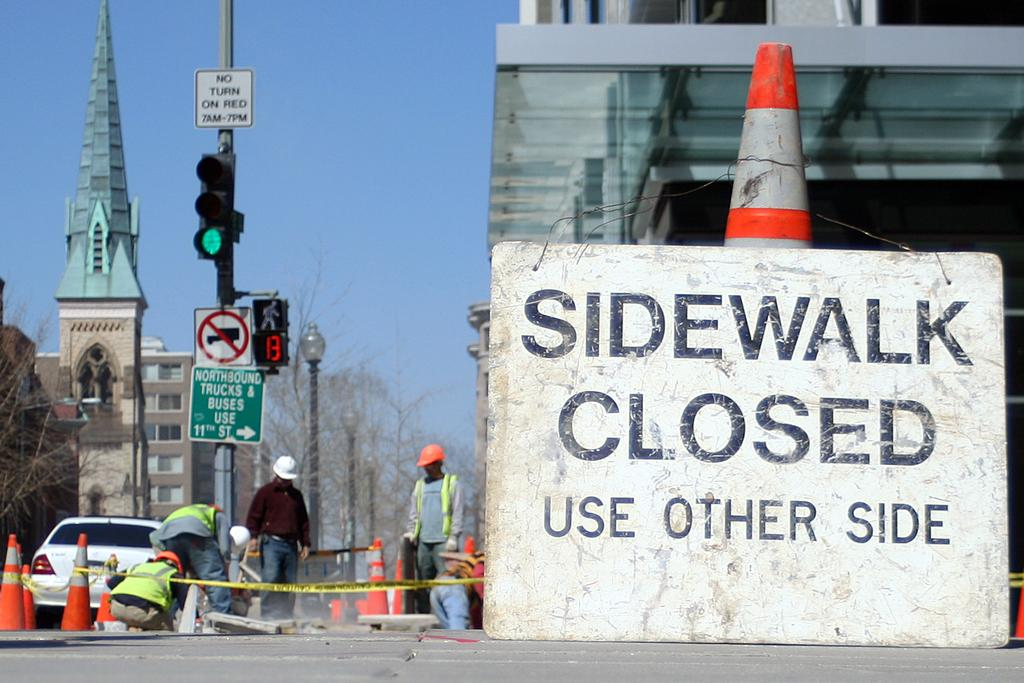<image>
Describe the image concisely. A construction zone with a huge sign stating Sidewalk closed, use other side. 